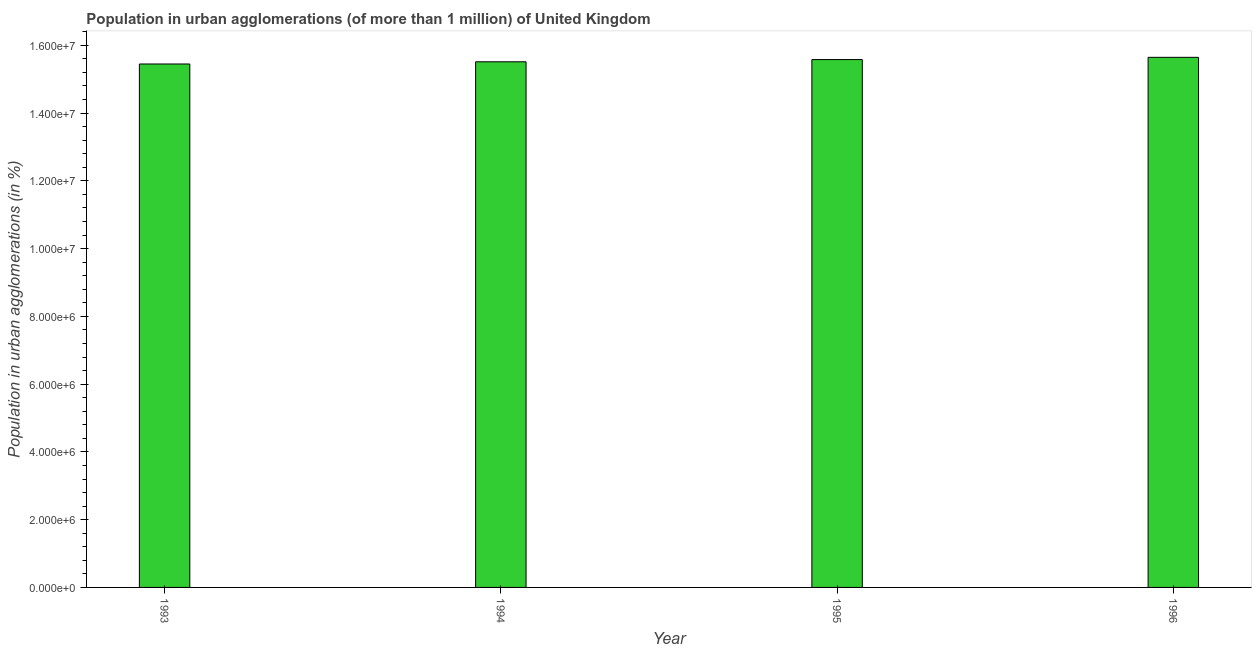Does the graph contain grids?
Provide a succinct answer. No. What is the title of the graph?
Provide a short and direct response. Population in urban agglomerations (of more than 1 million) of United Kingdom. What is the label or title of the X-axis?
Your answer should be very brief. Year. What is the label or title of the Y-axis?
Provide a succinct answer. Population in urban agglomerations (in %). What is the population in urban agglomerations in 1995?
Ensure brevity in your answer.  1.56e+07. Across all years, what is the maximum population in urban agglomerations?
Offer a very short reply. 1.56e+07. Across all years, what is the minimum population in urban agglomerations?
Offer a terse response. 1.54e+07. In which year was the population in urban agglomerations maximum?
Keep it short and to the point. 1996. What is the sum of the population in urban agglomerations?
Provide a short and direct response. 6.22e+07. What is the difference between the population in urban agglomerations in 1994 and 1996?
Offer a terse response. -1.31e+05. What is the average population in urban agglomerations per year?
Provide a succinct answer. 1.55e+07. What is the median population in urban agglomerations?
Give a very brief answer. 1.55e+07. Is the difference between the population in urban agglomerations in 1993 and 1994 greater than the difference between any two years?
Provide a short and direct response. No. What is the difference between the highest and the second highest population in urban agglomerations?
Provide a succinct answer. 6.60e+04. What is the difference between the highest and the lowest population in urban agglomerations?
Provide a succinct answer. 1.96e+05. Are all the bars in the graph horizontal?
Make the answer very short. No. How many years are there in the graph?
Ensure brevity in your answer.  4. Are the values on the major ticks of Y-axis written in scientific E-notation?
Ensure brevity in your answer.  Yes. What is the Population in urban agglomerations (in %) in 1993?
Make the answer very short. 1.54e+07. What is the Population in urban agglomerations (in %) in 1994?
Provide a short and direct response. 1.55e+07. What is the Population in urban agglomerations (in %) in 1995?
Ensure brevity in your answer.  1.56e+07. What is the Population in urban agglomerations (in %) of 1996?
Give a very brief answer. 1.56e+07. What is the difference between the Population in urban agglomerations (in %) in 1993 and 1994?
Make the answer very short. -6.50e+04. What is the difference between the Population in urban agglomerations (in %) in 1993 and 1995?
Give a very brief answer. -1.30e+05. What is the difference between the Population in urban agglomerations (in %) in 1993 and 1996?
Offer a very short reply. -1.96e+05. What is the difference between the Population in urban agglomerations (in %) in 1994 and 1995?
Offer a very short reply. -6.55e+04. What is the difference between the Population in urban agglomerations (in %) in 1994 and 1996?
Offer a very short reply. -1.31e+05. What is the difference between the Population in urban agglomerations (in %) in 1995 and 1996?
Keep it short and to the point. -6.60e+04. What is the ratio of the Population in urban agglomerations (in %) in 1993 to that in 1995?
Keep it short and to the point. 0.99. What is the ratio of the Population in urban agglomerations (in %) in 1993 to that in 1996?
Keep it short and to the point. 0.99. What is the ratio of the Population in urban agglomerations (in %) in 1995 to that in 1996?
Make the answer very short. 1. 